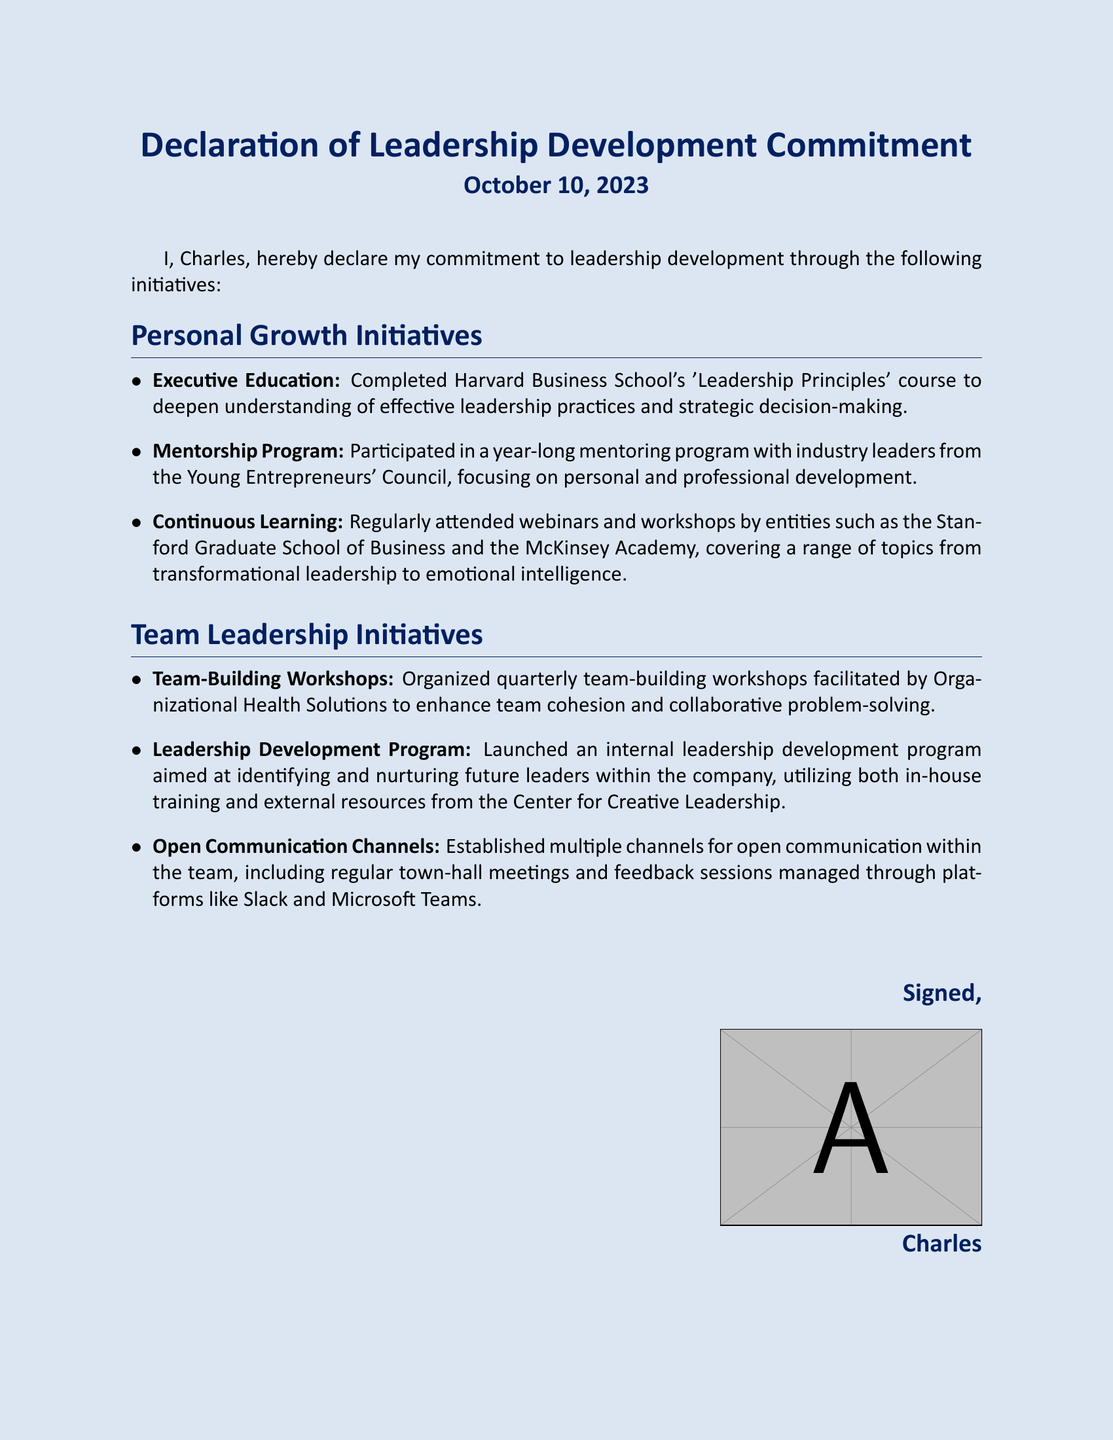What is the date of the declaration? The date of the declaration is clearly stated in the document.
Answer: October 10, 2023 Who completed the 'Leadership Principles' course? The individual committing to leadership development completed the course, as mentioned in the personal growth initiatives.
Answer: Charles What program did Charles participate in with industry leaders? This program focuses on personal and professional growth and is mentioned under personal growth initiatives.
Answer: Mentorship Program Which organization facilitated the team-building workshops? The document specifies the organization that facilitated these workshops under team leadership initiatives.
Answer: Organizational Health Solutions What type of program was launched to nurture future leaders? This program is key to team leadership initiatives, aiming to identify developing leaders.
Answer: Leadership Development Program What is the primary focus of the continuous learning initiatives? The continuous learning initiatives cover various topics to enhance leadership skills and capabilities.
Answer: Emotional Intelligence How often are the team-building workshops organized? The document specifies the frequency of these workshops in the relevant section.
Answer: Quarterly What platforms are used for open communication within the team? The document highlights these platforms as part of the open communication initiatives.
Answer: Slack and Microsoft Teams What is the main purpose of the 'Leadership Principles' course? The purpose of this course is aimed at improving effective leadership practices.
Answer: Strategic Decision-Making 